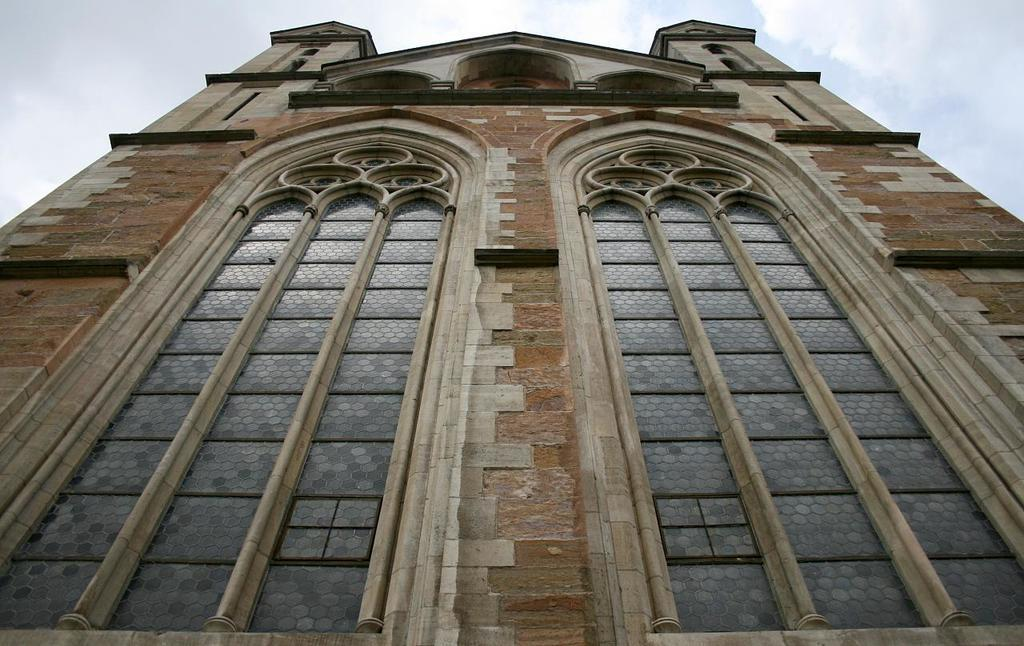What type of structure is present in the image? There is a building in the image. What architectural features can be seen on the building? The building has arches and a brick wall. What is visible in the background of the image? The sky is visible in the background of the image. What type of connection can be seen between the building and the bone in the image? There is no bone present in the image, and therefore no connection can be observed between the building and a bone. Where is the meeting taking place in the image? There is no meeting depicted in the image; it features a building with arches and a brick wall, and the sky visible in the background. 